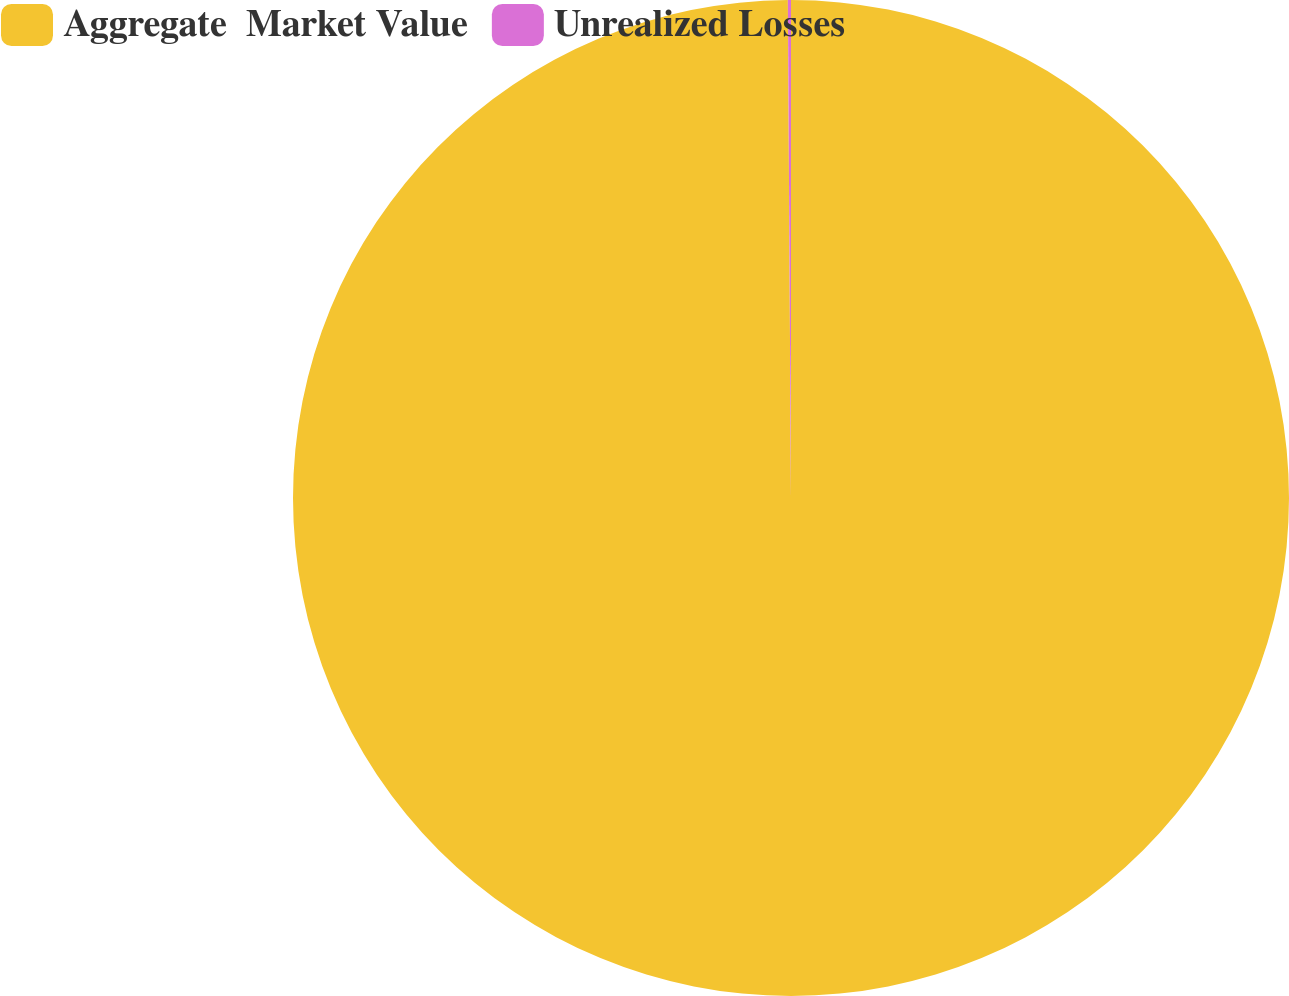Convert chart. <chart><loc_0><loc_0><loc_500><loc_500><pie_chart><fcel>Aggregate  Market Value<fcel>Unrealized Losses<nl><fcel>99.9%<fcel>0.1%<nl></chart> 